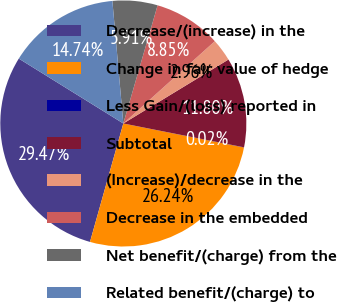Convert chart. <chart><loc_0><loc_0><loc_500><loc_500><pie_chart><fcel>Decrease/(increase) in the<fcel>Change in fair value of hedge<fcel>Less Gain/(loss) reported in<fcel>Subtotal<fcel>(Increase)/decrease in the<fcel>Decrease in the embedded<fcel>Net benefit/(charge) from the<fcel>Related benefit/(charge) to<nl><fcel>29.47%<fcel>26.24%<fcel>0.02%<fcel>11.8%<fcel>2.96%<fcel>8.85%<fcel>5.91%<fcel>14.74%<nl></chart> 